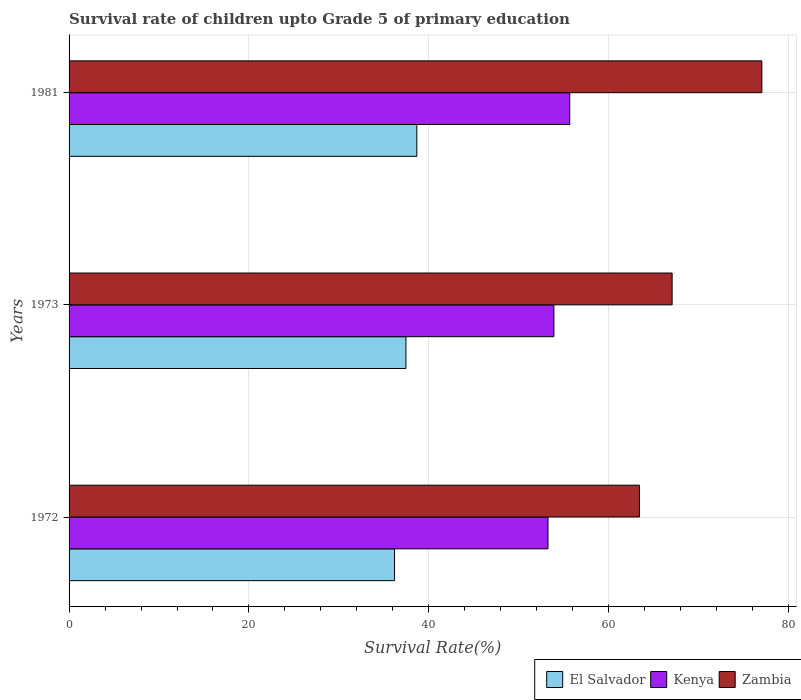How many different coloured bars are there?
Your answer should be very brief. 3. How many groups of bars are there?
Give a very brief answer. 3. Are the number of bars on each tick of the Y-axis equal?
Offer a very short reply. Yes. How many bars are there on the 2nd tick from the top?
Give a very brief answer. 3. What is the label of the 3rd group of bars from the top?
Offer a terse response. 1972. In how many cases, is the number of bars for a given year not equal to the number of legend labels?
Your answer should be very brief. 0. What is the survival rate of children in El Salvador in 1973?
Provide a succinct answer. 37.45. Across all years, what is the maximum survival rate of children in Kenya?
Provide a succinct answer. 55.66. Across all years, what is the minimum survival rate of children in Kenya?
Your answer should be compact. 53.24. In which year was the survival rate of children in Kenya maximum?
Keep it short and to the point. 1981. In which year was the survival rate of children in El Salvador minimum?
Make the answer very short. 1972. What is the total survival rate of children in Kenya in the graph?
Keep it short and to the point. 162.8. What is the difference between the survival rate of children in El Salvador in 1972 and that in 1981?
Your answer should be very brief. -2.48. What is the difference between the survival rate of children in Kenya in 1981 and the survival rate of children in El Salvador in 1973?
Your answer should be compact. 18.21. What is the average survival rate of children in Zambia per year?
Offer a very short reply. 69.16. In the year 1973, what is the difference between the survival rate of children in El Salvador and survival rate of children in Kenya?
Give a very brief answer. -16.45. What is the ratio of the survival rate of children in Zambia in 1973 to that in 1981?
Make the answer very short. 0.87. Is the survival rate of children in Zambia in 1972 less than that in 1973?
Provide a succinct answer. Yes. What is the difference between the highest and the second highest survival rate of children in Kenya?
Keep it short and to the point. 1.76. What is the difference between the highest and the lowest survival rate of children in Kenya?
Ensure brevity in your answer.  2.42. What does the 3rd bar from the top in 1973 represents?
Ensure brevity in your answer.  El Salvador. What does the 3rd bar from the bottom in 1973 represents?
Give a very brief answer. Zambia. Are all the bars in the graph horizontal?
Ensure brevity in your answer.  Yes. What is the difference between two consecutive major ticks on the X-axis?
Ensure brevity in your answer.  20. Does the graph contain any zero values?
Ensure brevity in your answer.  No. Does the graph contain grids?
Ensure brevity in your answer.  Yes. What is the title of the graph?
Offer a terse response. Survival rate of children upto Grade 5 of primary education. Does "Uganda" appear as one of the legend labels in the graph?
Your answer should be very brief. No. What is the label or title of the X-axis?
Ensure brevity in your answer.  Survival Rate(%). What is the Survival Rate(%) in El Salvador in 1972?
Offer a very short reply. 36.19. What is the Survival Rate(%) of Kenya in 1972?
Your answer should be very brief. 53.24. What is the Survival Rate(%) in Zambia in 1972?
Ensure brevity in your answer.  63.41. What is the Survival Rate(%) of El Salvador in 1973?
Give a very brief answer. 37.45. What is the Survival Rate(%) in Kenya in 1973?
Your response must be concise. 53.9. What is the Survival Rate(%) of Zambia in 1973?
Your answer should be compact. 67.04. What is the Survival Rate(%) of El Salvador in 1981?
Your answer should be very brief. 38.66. What is the Survival Rate(%) in Kenya in 1981?
Give a very brief answer. 55.66. What is the Survival Rate(%) in Zambia in 1981?
Provide a succinct answer. 77.02. Across all years, what is the maximum Survival Rate(%) in El Salvador?
Offer a terse response. 38.66. Across all years, what is the maximum Survival Rate(%) of Kenya?
Offer a terse response. 55.66. Across all years, what is the maximum Survival Rate(%) of Zambia?
Offer a terse response. 77.02. Across all years, what is the minimum Survival Rate(%) of El Salvador?
Ensure brevity in your answer.  36.19. Across all years, what is the minimum Survival Rate(%) of Kenya?
Make the answer very short. 53.24. Across all years, what is the minimum Survival Rate(%) of Zambia?
Ensure brevity in your answer.  63.41. What is the total Survival Rate(%) in El Salvador in the graph?
Ensure brevity in your answer.  112.3. What is the total Survival Rate(%) of Kenya in the graph?
Keep it short and to the point. 162.8. What is the total Survival Rate(%) of Zambia in the graph?
Give a very brief answer. 207.48. What is the difference between the Survival Rate(%) in El Salvador in 1972 and that in 1973?
Your answer should be very brief. -1.26. What is the difference between the Survival Rate(%) in Kenya in 1972 and that in 1973?
Provide a short and direct response. -0.66. What is the difference between the Survival Rate(%) of Zambia in 1972 and that in 1973?
Offer a very short reply. -3.63. What is the difference between the Survival Rate(%) in El Salvador in 1972 and that in 1981?
Make the answer very short. -2.48. What is the difference between the Survival Rate(%) in Kenya in 1972 and that in 1981?
Ensure brevity in your answer.  -2.42. What is the difference between the Survival Rate(%) in Zambia in 1972 and that in 1981?
Ensure brevity in your answer.  -13.61. What is the difference between the Survival Rate(%) of El Salvador in 1973 and that in 1981?
Your answer should be very brief. -1.21. What is the difference between the Survival Rate(%) in Kenya in 1973 and that in 1981?
Give a very brief answer. -1.76. What is the difference between the Survival Rate(%) in Zambia in 1973 and that in 1981?
Offer a terse response. -9.98. What is the difference between the Survival Rate(%) in El Salvador in 1972 and the Survival Rate(%) in Kenya in 1973?
Give a very brief answer. -17.71. What is the difference between the Survival Rate(%) of El Salvador in 1972 and the Survival Rate(%) of Zambia in 1973?
Provide a short and direct response. -30.86. What is the difference between the Survival Rate(%) of Kenya in 1972 and the Survival Rate(%) of Zambia in 1973?
Make the answer very short. -13.8. What is the difference between the Survival Rate(%) in El Salvador in 1972 and the Survival Rate(%) in Kenya in 1981?
Offer a terse response. -19.48. What is the difference between the Survival Rate(%) in El Salvador in 1972 and the Survival Rate(%) in Zambia in 1981?
Provide a succinct answer. -40.83. What is the difference between the Survival Rate(%) in Kenya in 1972 and the Survival Rate(%) in Zambia in 1981?
Make the answer very short. -23.78. What is the difference between the Survival Rate(%) in El Salvador in 1973 and the Survival Rate(%) in Kenya in 1981?
Your response must be concise. -18.21. What is the difference between the Survival Rate(%) of El Salvador in 1973 and the Survival Rate(%) of Zambia in 1981?
Ensure brevity in your answer.  -39.57. What is the difference between the Survival Rate(%) in Kenya in 1973 and the Survival Rate(%) in Zambia in 1981?
Offer a terse response. -23.12. What is the average Survival Rate(%) of El Salvador per year?
Make the answer very short. 37.43. What is the average Survival Rate(%) in Kenya per year?
Your answer should be compact. 54.27. What is the average Survival Rate(%) of Zambia per year?
Ensure brevity in your answer.  69.16. In the year 1972, what is the difference between the Survival Rate(%) in El Salvador and Survival Rate(%) in Kenya?
Offer a very short reply. -17.06. In the year 1972, what is the difference between the Survival Rate(%) of El Salvador and Survival Rate(%) of Zambia?
Your answer should be compact. -27.23. In the year 1972, what is the difference between the Survival Rate(%) of Kenya and Survival Rate(%) of Zambia?
Make the answer very short. -10.17. In the year 1973, what is the difference between the Survival Rate(%) of El Salvador and Survival Rate(%) of Kenya?
Offer a terse response. -16.45. In the year 1973, what is the difference between the Survival Rate(%) in El Salvador and Survival Rate(%) in Zambia?
Provide a succinct answer. -29.59. In the year 1973, what is the difference between the Survival Rate(%) of Kenya and Survival Rate(%) of Zambia?
Give a very brief answer. -13.15. In the year 1981, what is the difference between the Survival Rate(%) in El Salvador and Survival Rate(%) in Kenya?
Offer a terse response. -17. In the year 1981, what is the difference between the Survival Rate(%) of El Salvador and Survival Rate(%) of Zambia?
Your response must be concise. -38.36. In the year 1981, what is the difference between the Survival Rate(%) of Kenya and Survival Rate(%) of Zambia?
Your answer should be very brief. -21.36. What is the ratio of the Survival Rate(%) in El Salvador in 1972 to that in 1973?
Your response must be concise. 0.97. What is the ratio of the Survival Rate(%) in Zambia in 1972 to that in 1973?
Give a very brief answer. 0.95. What is the ratio of the Survival Rate(%) of El Salvador in 1972 to that in 1981?
Give a very brief answer. 0.94. What is the ratio of the Survival Rate(%) of Kenya in 1972 to that in 1981?
Offer a very short reply. 0.96. What is the ratio of the Survival Rate(%) in Zambia in 1972 to that in 1981?
Ensure brevity in your answer.  0.82. What is the ratio of the Survival Rate(%) of El Salvador in 1973 to that in 1981?
Your response must be concise. 0.97. What is the ratio of the Survival Rate(%) in Kenya in 1973 to that in 1981?
Offer a terse response. 0.97. What is the ratio of the Survival Rate(%) of Zambia in 1973 to that in 1981?
Provide a succinct answer. 0.87. What is the difference between the highest and the second highest Survival Rate(%) in El Salvador?
Your answer should be compact. 1.21. What is the difference between the highest and the second highest Survival Rate(%) in Kenya?
Provide a succinct answer. 1.76. What is the difference between the highest and the second highest Survival Rate(%) of Zambia?
Your answer should be compact. 9.98. What is the difference between the highest and the lowest Survival Rate(%) in El Salvador?
Offer a terse response. 2.48. What is the difference between the highest and the lowest Survival Rate(%) in Kenya?
Make the answer very short. 2.42. What is the difference between the highest and the lowest Survival Rate(%) in Zambia?
Offer a very short reply. 13.61. 